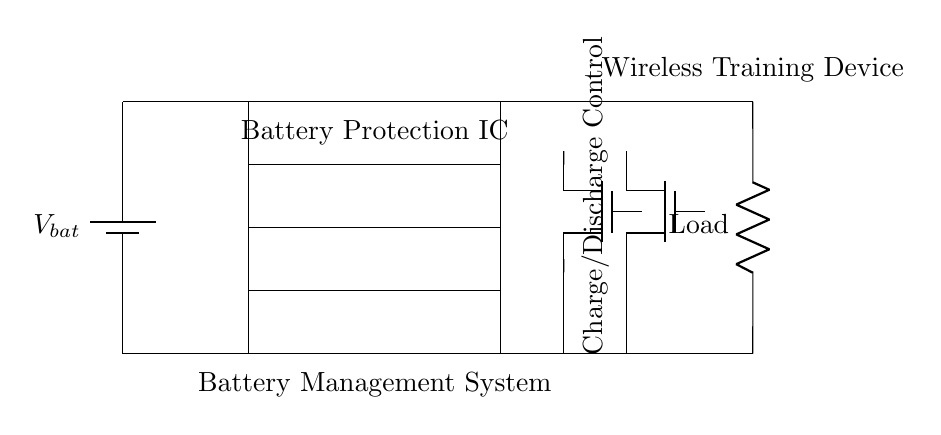What is the primary component providing overcurrent protection? The primary component for overcurrent protection in the circuit is a four-port device labeled OCP. This indicates its role in managing and preventing excessive current flow.
Answer: OCP What is the purpose of the Battery Protection IC? The Battery Protection IC is designed to manage the battery's state, providing essential protections, including overvoltage, undervoltage, and overcurrent, to ensure safe operation.
Answer: Battery Protection IC Which type of switches are used for charge and discharge control? The circuit uses N-channel MOSFET switches, labeled CHG for charging and DSG for discharging, to control the direction of current flow effectively.
Answer: N-channel MOSFET switches What does the OVP stand for in this circuit? OVP stands for Overvoltage Protection, identified by the four-port device in the circuit that safeguards the battery from exceeding its voltage limits.
Answer: Overvoltage Protection Explain the relationship between the Battery Management System and the wireless training device. The Battery Management System is crucial for regulating and protecting the battery used in the wireless training device. It ensures that the device operates within safe voltage and current levels, thereby enhancing performance and longevity.
Answer: Regulating and protecting battery What would happen if the undervoltage protection (UVP) is triggered? If the undervoltage protection (UVP) is triggered, it will disconnect the load from the battery to prevent deep discharge, which can damage the battery cells and reduce lifespan.
Answer: Disconnect load How many protection circuits are present in the circuit? There are three protection circuits present: Overcurrent Protection, Overvoltage Protection, and Undervoltage Protection, each represented by a separate four-port device.
Answer: Three 